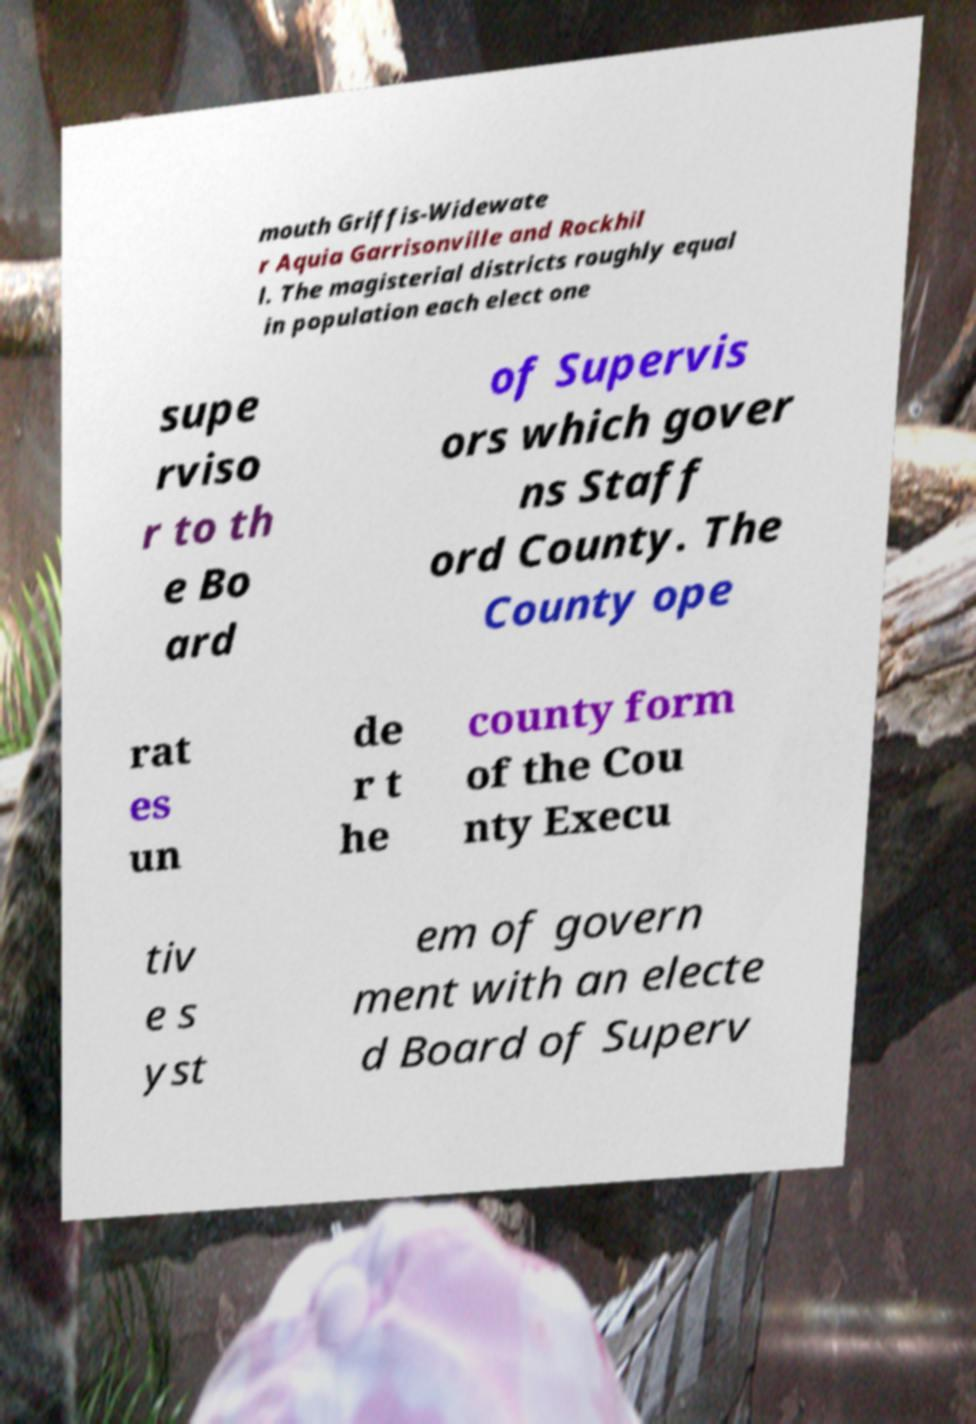There's text embedded in this image that I need extracted. Can you transcribe it verbatim? mouth Griffis-Widewate r Aquia Garrisonville and Rockhil l. The magisterial districts roughly equal in population each elect one supe rviso r to th e Bo ard of Supervis ors which gover ns Staff ord County. The County ope rat es un de r t he county form of the Cou nty Execu tiv e s yst em of govern ment with an electe d Board of Superv 